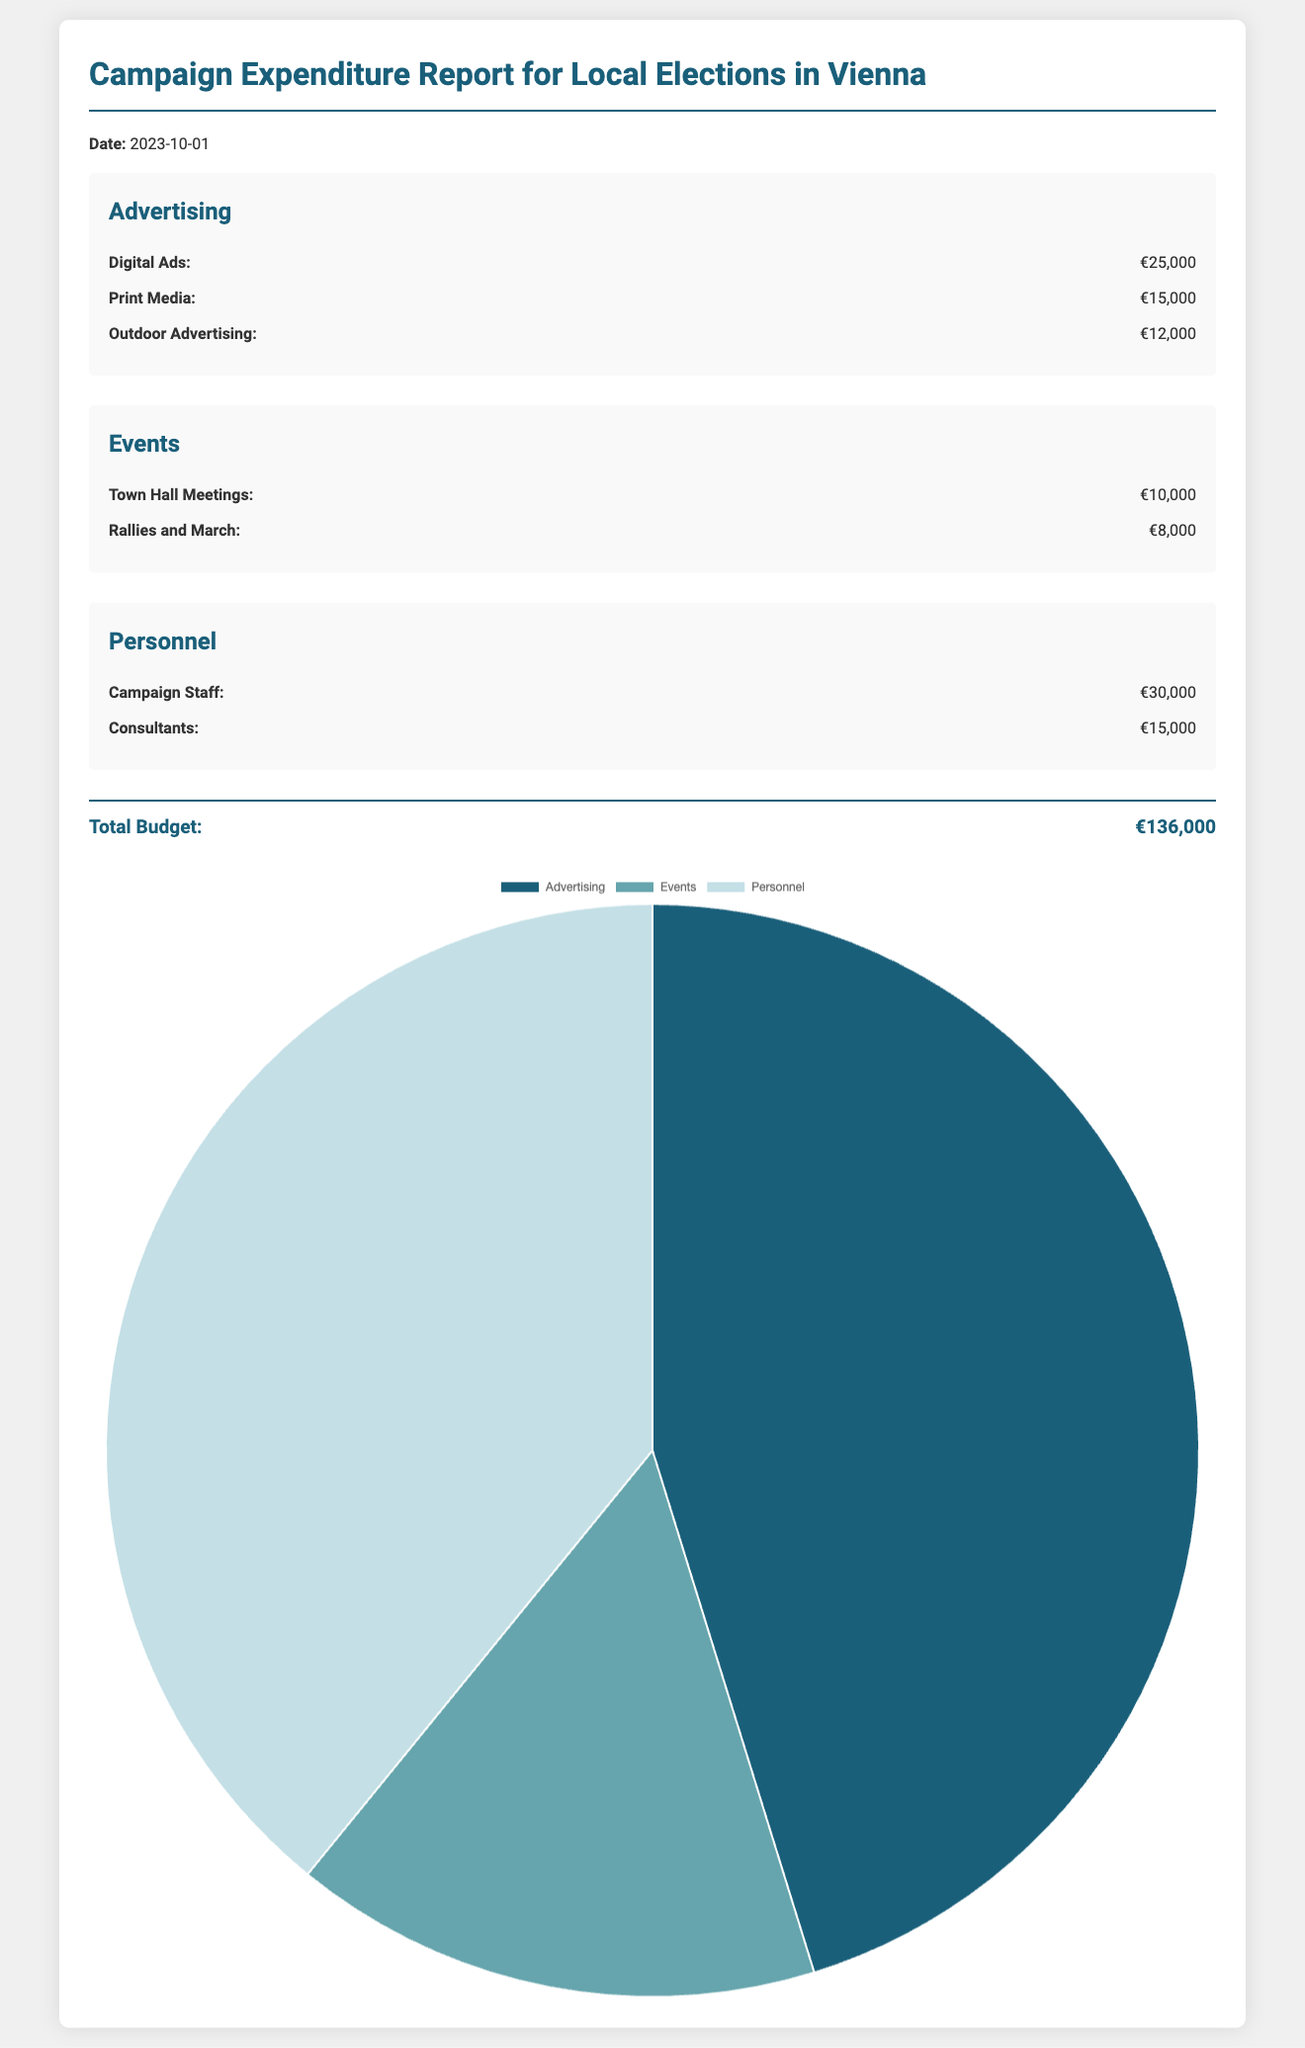what is the date of the report? The date of the report is clearly stated in the document.
Answer: 2023-10-01 what is the total budget for the campaign? The total budget is indicated in the total section of the document.
Answer: €136,000 how much was spent on digital ads? The amount spent on digital ads is listed in the advertising section.
Answer: €25,000 what is the cost of campaign staff? The cost for campaign staff is provided under the personnel section.
Answer: €30,000 which event category has the highest expenditure? The expenditures across event categories suggest the one with the highest amount.
Answer: Town Hall Meetings how much total was spent on events? The total for events can be found by adding the costs listed under the events section.
Answer: €18,000 what percentage of the total budget is allocated to advertising? This requires calculating the proportion of advertising spending relative to the total budget.
Answer: 38.24% how many cost items are listed in the document? The number of cost items can be counted from all sections in the document.
Answer: 7 what type of chart is used to represent the budget distribution? The document specifies the type of chart used for this representation.
Answer: Pie chart 